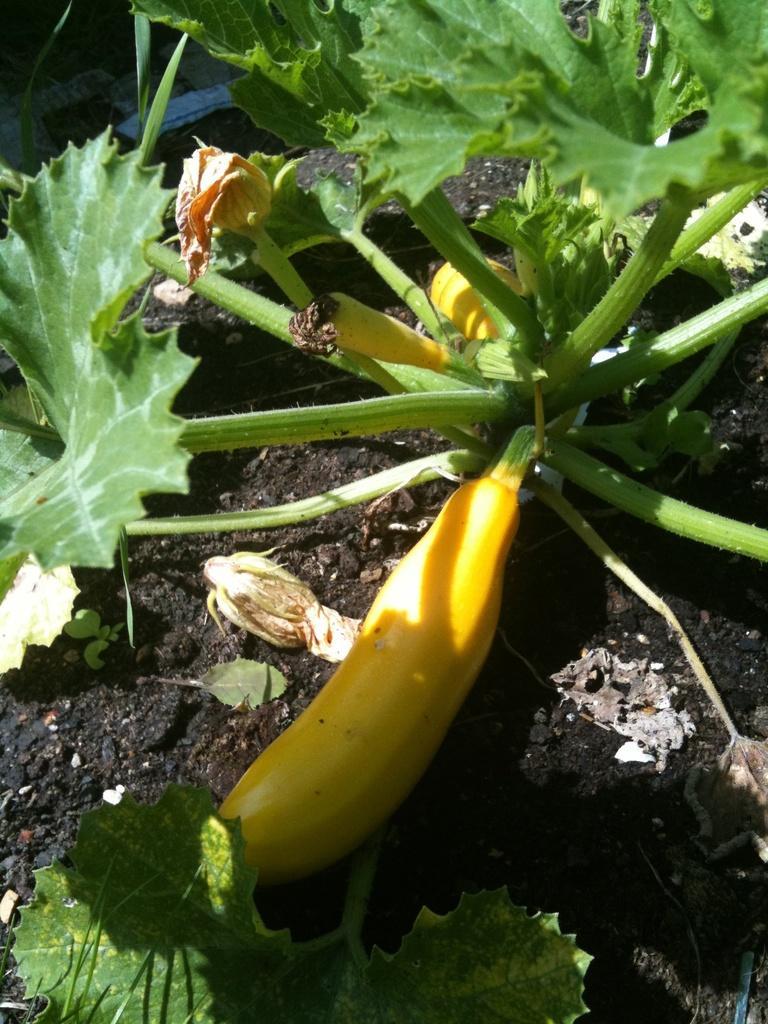In one or two sentences, can you explain what this image depicts? In this image there is a vegetable plant with leaves on the surface. 